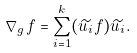<formula> <loc_0><loc_0><loc_500><loc_500>\nabla _ { g } f = \sum _ { i = 1 } ^ { k } ( \widetilde { u _ { i } } f ) \widetilde { u _ { i } } .</formula> 